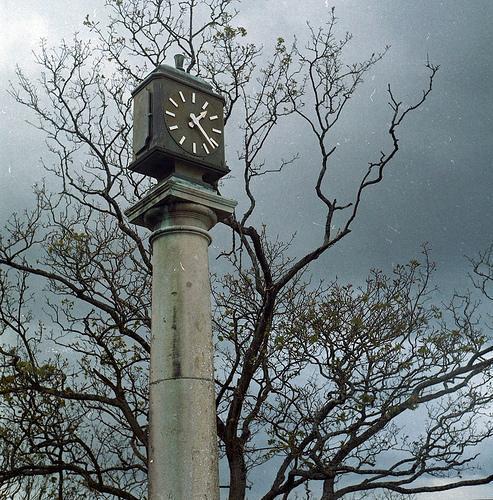How many poles are pictured?
Give a very brief answer. 1. 